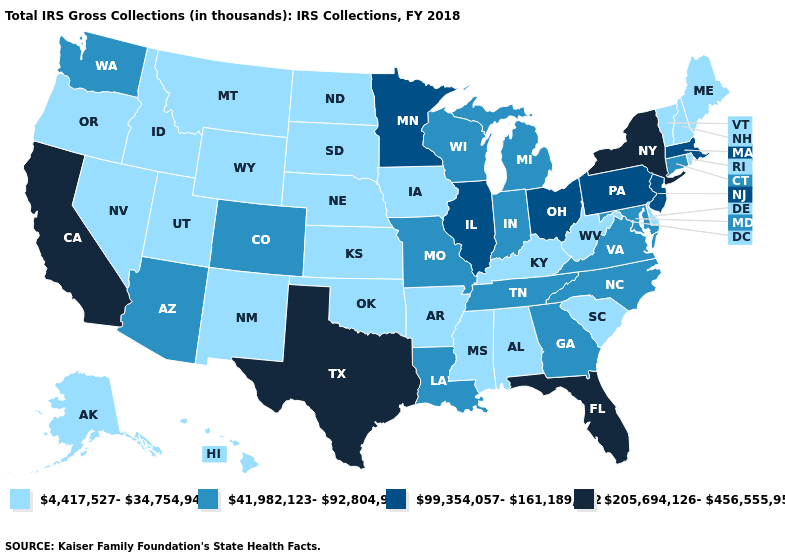What is the value of Alabama?
Give a very brief answer. 4,417,527-34,754,947. What is the lowest value in the West?
Give a very brief answer. 4,417,527-34,754,947. Name the states that have a value in the range 99,354,057-161,189,282?
Short answer required. Illinois, Massachusetts, Minnesota, New Jersey, Ohio, Pennsylvania. Does North Dakota have the lowest value in the MidWest?
Quick response, please. Yes. What is the value of Michigan?
Be succinct. 41,982,123-92,804,948. Which states have the lowest value in the West?
Keep it brief. Alaska, Hawaii, Idaho, Montana, Nevada, New Mexico, Oregon, Utah, Wyoming. Which states have the lowest value in the USA?
Concise answer only. Alabama, Alaska, Arkansas, Delaware, Hawaii, Idaho, Iowa, Kansas, Kentucky, Maine, Mississippi, Montana, Nebraska, Nevada, New Hampshire, New Mexico, North Dakota, Oklahoma, Oregon, Rhode Island, South Carolina, South Dakota, Utah, Vermont, West Virginia, Wyoming. Does Iowa have the same value as Mississippi?
Be succinct. Yes. Among the states that border Wyoming , does Colorado have the highest value?
Concise answer only. Yes. Which states have the lowest value in the USA?
Concise answer only. Alabama, Alaska, Arkansas, Delaware, Hawaii, Idaho, Iowa, Kansas, Kentucky, Maine, Mississippi, Montana, Nebraska, Nevada, New Hampshire, New Mexico, North Dakota, Oklahoma, Oregon, Rhode Island, South Carolina, South Dakota, Utah, Vermont, West Virginia, Wyoming. Does the map have missing data?
Write a very short answer. No. What is the value of Oregon?
Short answer required. 4,417,527-34,754,947. Among the states that border Iowa , does South Dakota have the highest value?
Quick response, please. No. What is the lowest value in the USA?
Short answer required. 4,417,527-34,754,947. Name the states that have a value in the range 99,354,057-161,189,282?
Concise answer only. Illinois, Massachusetts, Minnesota, New Jersey, Ohio, Pennsylvania. 